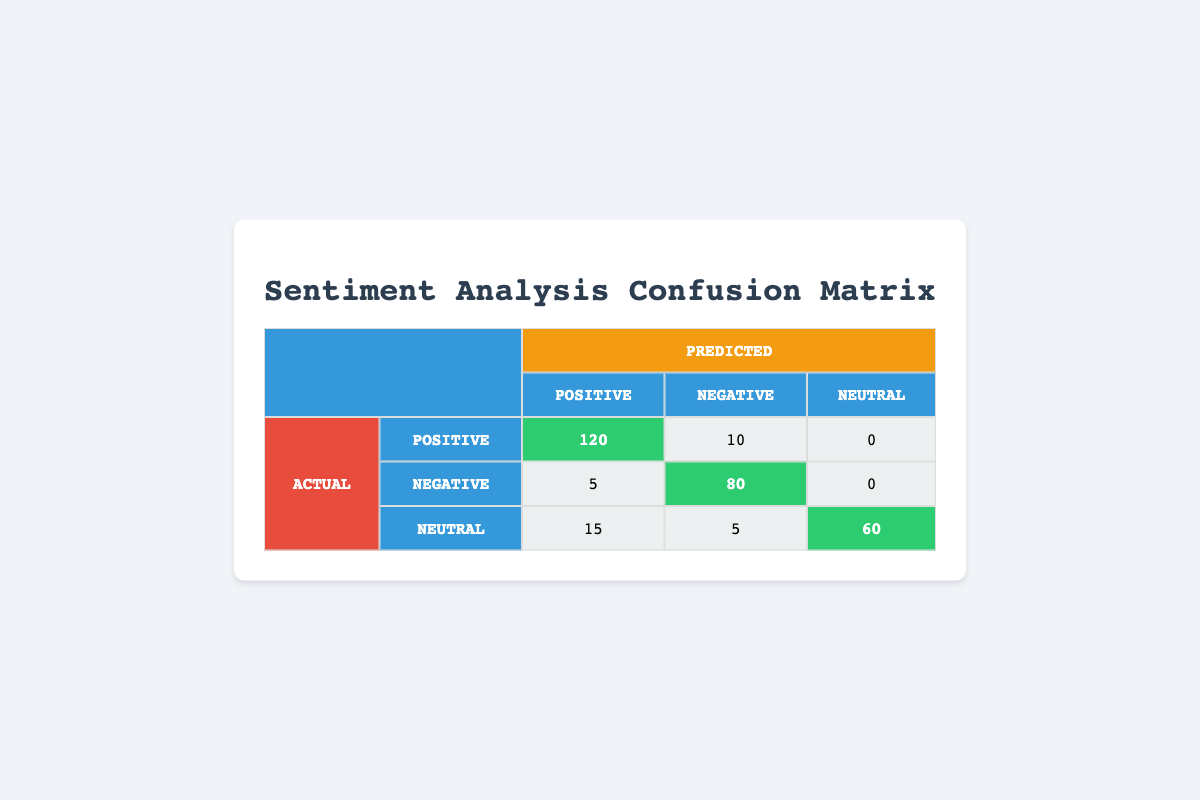What is the count of actual Positive reviews that were predicted as Positive? From the table, we can see that the count of actual Positive reviews that were predicted as Positive is shown in the corresponding cell of the first row and the first column, which is 120.
Answer: 120 What is the count of actual Negative reviews that were predicted as Negative? Referring to the confusion matrix, the count of actual Negative reviews that were predicted as Negative can be found in the second row and the second column of the table, which indicates a count of 80.
Answer: 80 How many Neutral reviews were predicted as Positive? Looking at the row labeled "Neutral" and the column labeled "Positive", the count in that cell is 15, indicating that there were 15 Neutral reviews predicted as Positive.
Answer: 15 What is the total number of actual Positive reviews? To find the total number of actual Positive reviews, we need to sum the counts of actual Positive reviews that were predicted as Positive (120) and those predicted as Negative (10). Thus, total = 120 + 10 = 130.
Answer: 130 Are there more actual Neutral reviews predicted as Neutral than actual Negative reviews predicted as Negative? From the data, the count of actual Neutral reviews predicted as Neutral is 60, while the count of actual Negative reviews predicted as Negative is 80. Therefore, this statement is false since 60 is not greater than 80.
Answer: No What is the proportion of actual Positive reviews that were predicted as Negative? The count of actual Positive reviews predicted as Negative is 10, and the total count of actual Positive reviews is 130. To calculate the proportion, we divide 10 by 130, which results in a proportion of 10/130 = 0.0769 (approximately 0.077).
Answer: 0.077 What is the total number of reviews classified as Neutral? To determine the total number of reviews classified as Neutral, we take the counts in the Neutral row: Neutral predicted as Positive (15), predicted as Negative (5), and predicted as Neutral (60). Summing these gives 15 + 5 + 60 = 80.
Answer: 80 What percentage of actual Positive reviews were predicted correctly? The correct predictions for actual Positive reviews are 120 (predicted as Positive). To find the percentage, we use the formula: (correct predictions / total actual Positive reviews) * 100 = (120 / 130) * 100 = 92.31%.
Answer: 92.31% How many total reviews were classified as Negative? For total negative classifications, we add the counts across the Negative column: actual Positive predicted as Negative (10), actual Negative predicted as Negative (80), and actual Neutral predicted as Negative (5). This totals: 10 + 80 + 5 = 95.
Answer: 95 